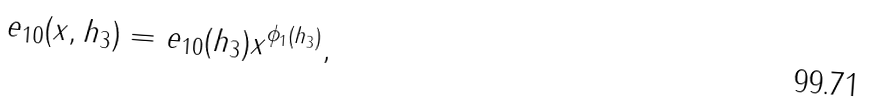<formula> <loc_0><loc_0><loc_500><loc_500>e _ { 1 0 } ( x , h _ { 3 } ) = e _ { 1 0 } ( h _ { 3 } ) x ^ { \phi _ { 1 } ( h _ { 3 } ) } ,</formula> 